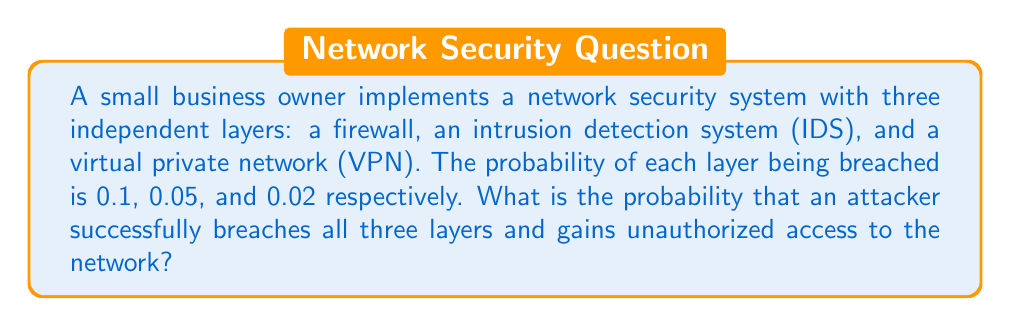Can you answer this question? To solve this problem, we need to follow these steps:

1) First, we need to understand that for an attacker to successfully breach the network, they must bypass all three security layers.

2) Since the layers are independent, we can use the multiplication rule of probability. This rule states that for independent events, the probability of all events occurring is the product of their individual probabilities.

3) Let's define our events:
   A: Breaching the firewall (probability = 0.1)
   B: Breaching the IDS (probability = 0.05)
   C: Breaching the VPN (probability = 0.02)

4) We want to find P(A ∩ B ∩ C), which is the probability of all three events occurring.

5) Using the multiplication rule:

   $$P(A \cap B \cap C) = P(A) \times P(B) \times P(C)$$

6) Substituting the given probabilities:

   $$P(A \cap B \cap C) = 0.1 \times 0.05 \times 0.02$$

7) Calculating:

   $$P(A \cap B \cap C) = 0.0001$$

Therefore, the probability of an attacker successfully breaching all three layers is 0.0001 or 0.01%.
Answer: 0.0001 